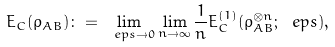Convert formula to latex. <formula><loc_0><loc_0><loc_500><loc_500>E _ { C } ( \rho _ { A B } ) \colon = \lim _ { \ e p s \to 0 } \lim _ { n \to \infty } \frac { 1 } { n } E _ { C } ^ { ( 1 ) } ( \rho _ { A B } ^ { \otimes n } ; \ e p s ) ,</formula> 